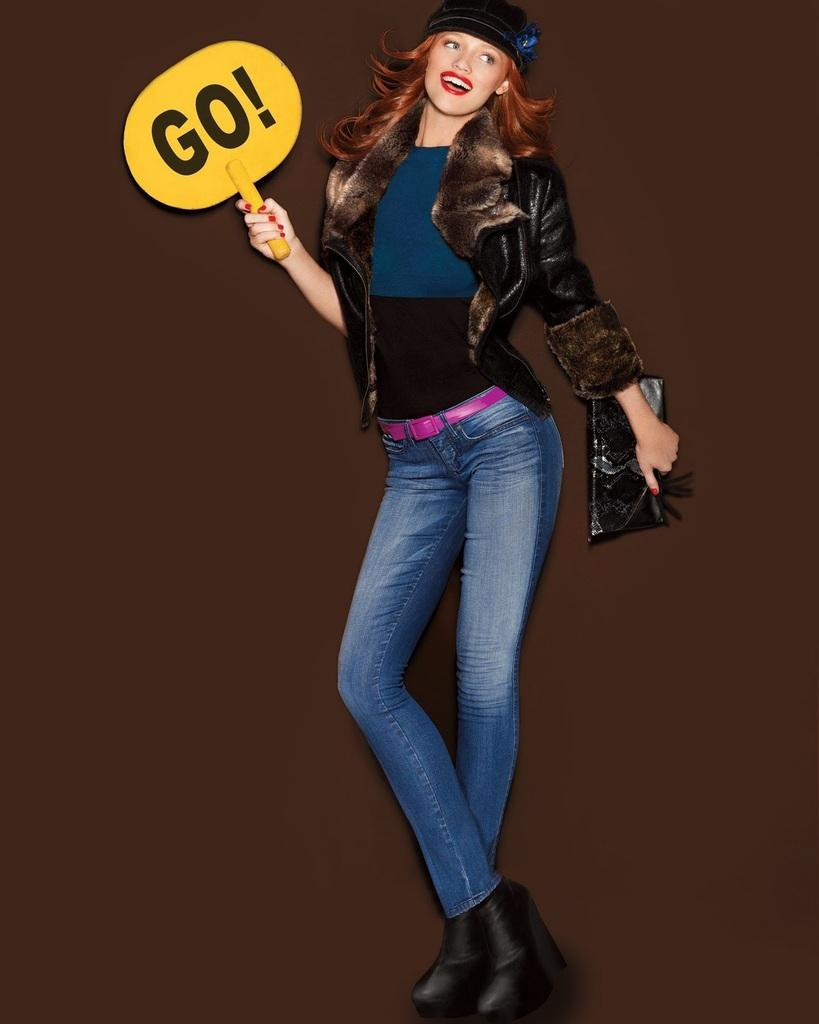Who is the main subject in the image? There is a woman in the image. What is the woman doing in the image? The woman is standing and holding a stop sign board. What can be seen in the background of the image? The background of the image is brown. What type of nose can be seen on the lock in the image? There is no lock or nose present in the image; it features a woman holding a stop sign board with a brown background. 